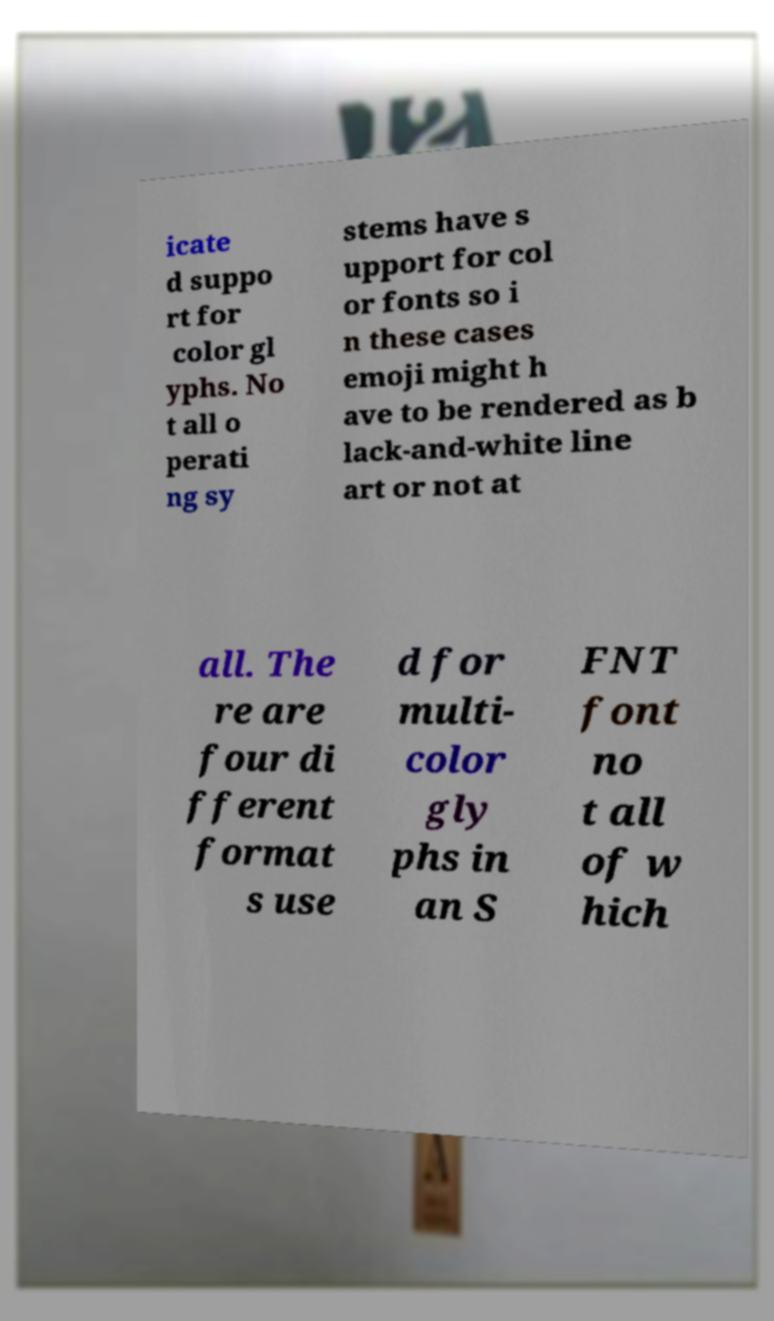Can you read and provide the text displayed in the image?This photo seems to have some interesting text. Can you extract and type it out for me? icate d suppo rt for color gl yphs. No t all o perati ng sy stems have s upport for col or fonts so i n these cases emoji might h ave to be rendered as b lack-and-white line art or not at all. The re are four di fferent format s use d for multi- color gly phs in an S FNT font no t all of w hich 